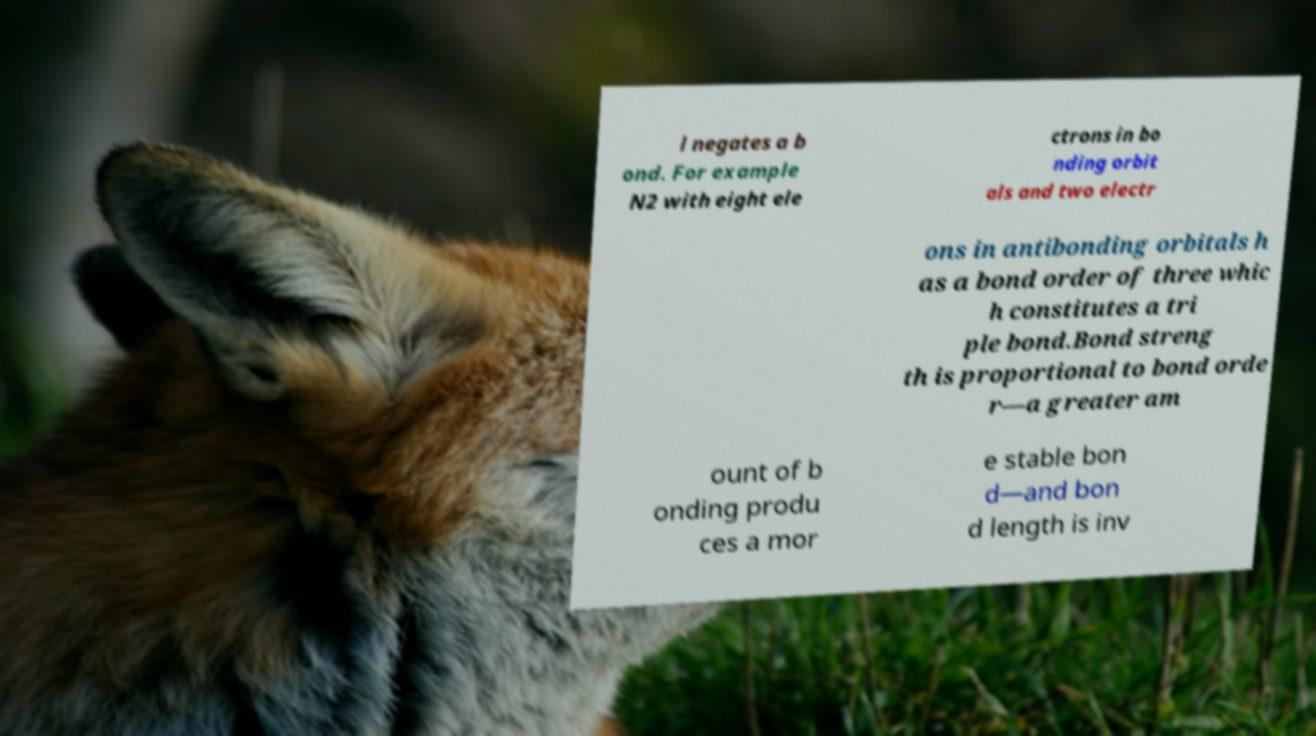Can you accurately transcribe the text from the provided image for me? l negates a b ond. For example N2 with eight ele ctrons in bo nding orbit als and two electr ons in antibonding orbitals h as a bond order of three whic h constitutes a tri ple bond.Bond streng th is proportional to bond orde r—a greater am ount of b onding produ ces a mor e stable bon d—and bon d length is inv 